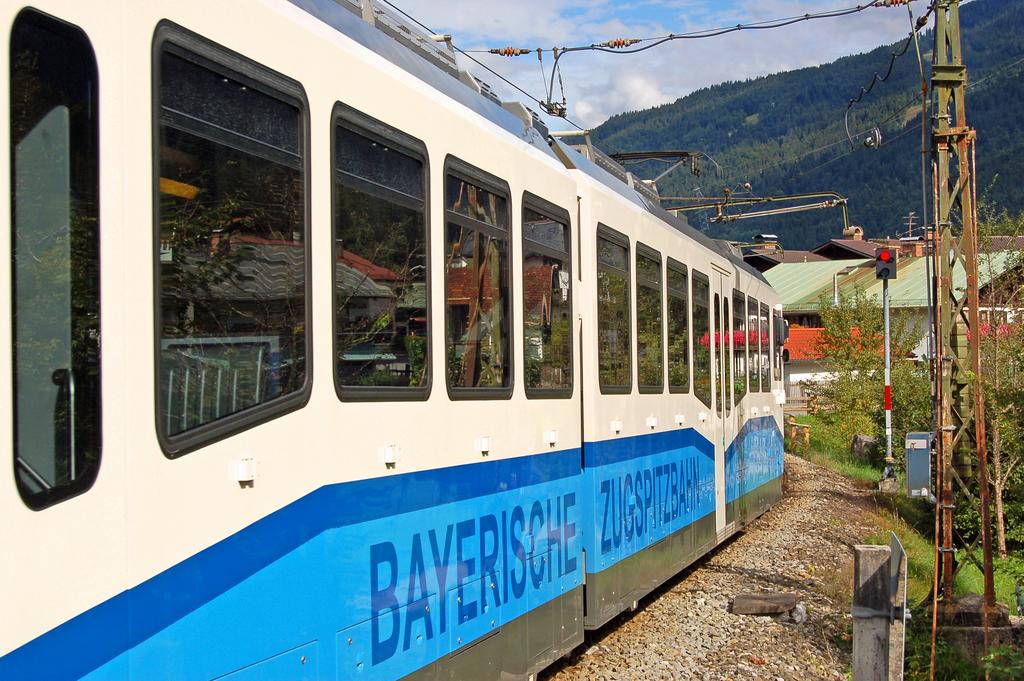What does the side of the train say?
Provide a succinct answer. Bayerische zugspitzbahn. 